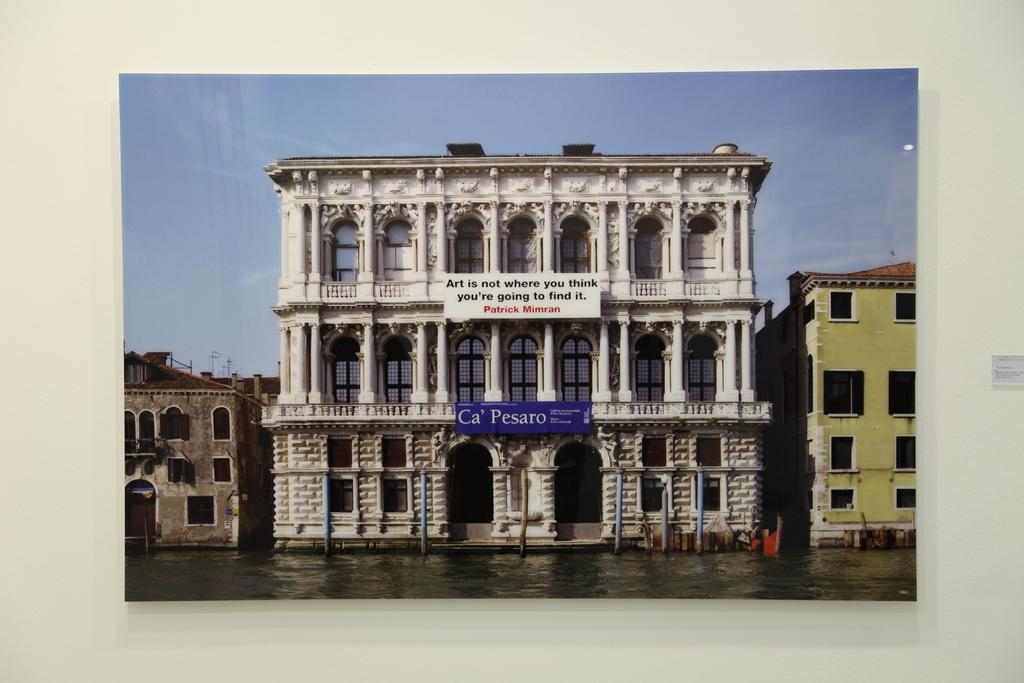What type of building is the main subject of the image? There is a heritage building in the image. What can be seen on the heritage building? The heritage building has text on it. What else is present in the image besides the heritage building? There are stands in the image. What type of buildings can be seen in the image? There are buildings with windows in the image. What is visible in the background of the image? The sky is visible in the background of the image. What time of day is it in the image, given the presence of the ant? There is no ant present in the image, so we cannot determine the time of day based on its presence. 